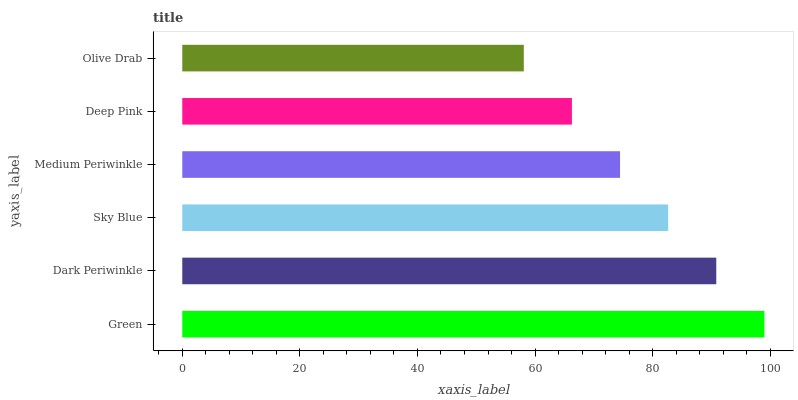Is Olive Drab the minimum?
Answer yes or no. Yes. Is Green the maximum?
Answer yes or no. Yes. Is Dark Periwinkle the minimum?
Answer yes or no. No. Is Dark Periwinkle the maximum?
Answer yes or no. No. Is Green greater than Dark Periwinkle?
Answer yes or no. Yes. Is Dark Periwinkle less than Green?
Answer yes or no. Yes. Is Dark Periwinkle greater than Green?
Answer yes or no. No. Is Green less than Dark Periwinkle?
Answer yes or no. No. Is Sky Blue the high median?
Answer yes or no. Yes. Is Medium Periwinkle the low median?
Answer yes or no. Yes. Is Dark Periwinkle the high median?
Answer yes or no. No. Is Green the low median?
Answer yes or no. No. 